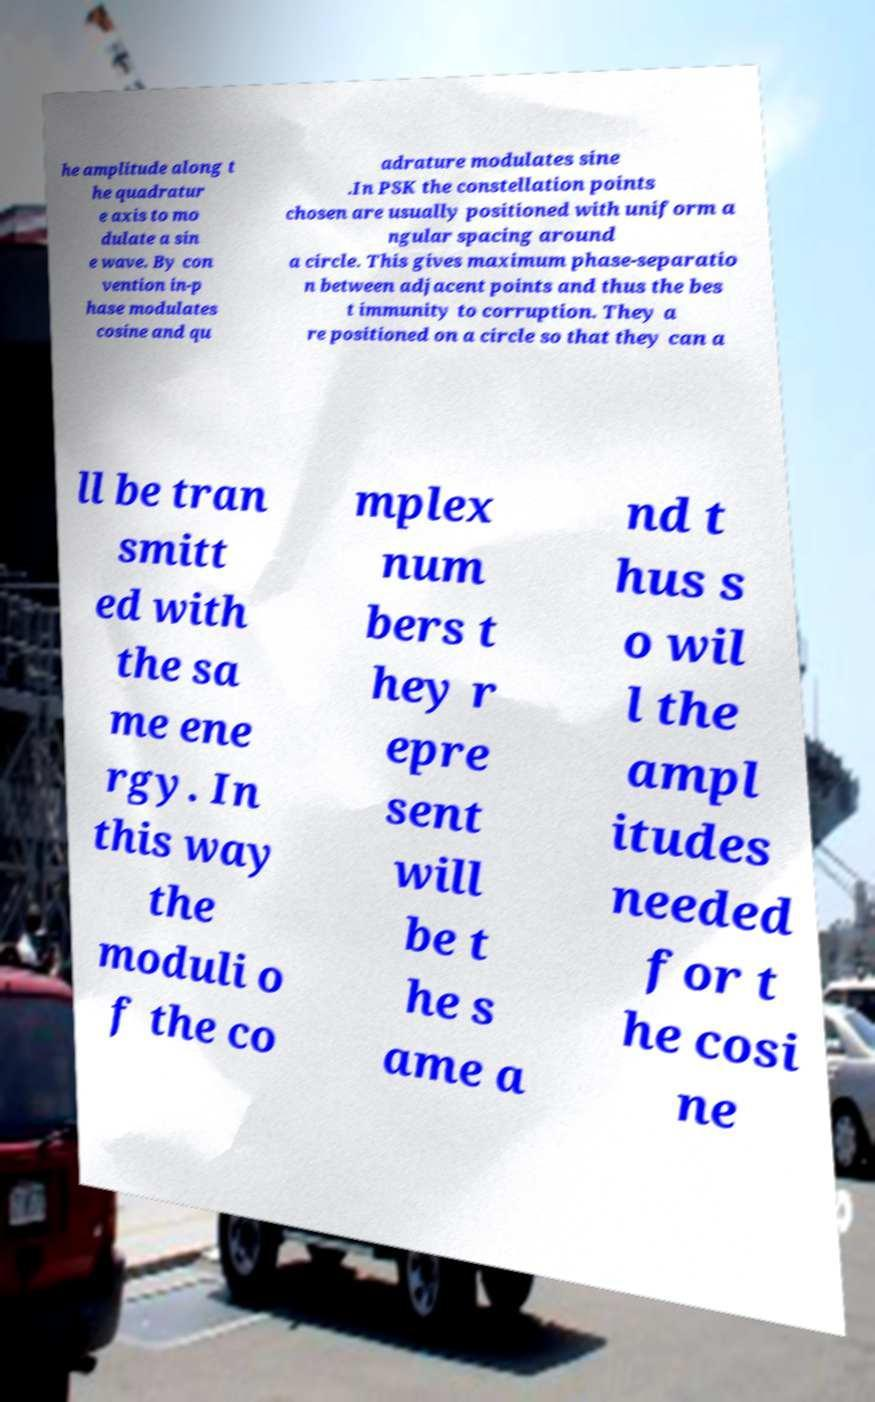For documentation purposes, I need the text within this image transcribed. Could you provide that? he amplitude along t he quadratur e axis to mo dulate a sin e wave. By con vention in-p hase modulates cosine and qu adrature modulates sine .In PSK the constellation points chosen are usually positioned with uniform a ngular spacing around a circle. This gives maximum phase-separatio n between adjacent points and thus the bes t immunity to corruption. They a re positioned on a circle so that they can a ll be tran smitt ed with the sa me ene rgy. In this way the moduli o f the co mplex num bers t hey r epre sent will be t he s ame a nd t hus s o wil l the ampl itudes needed for t he cosi ne 